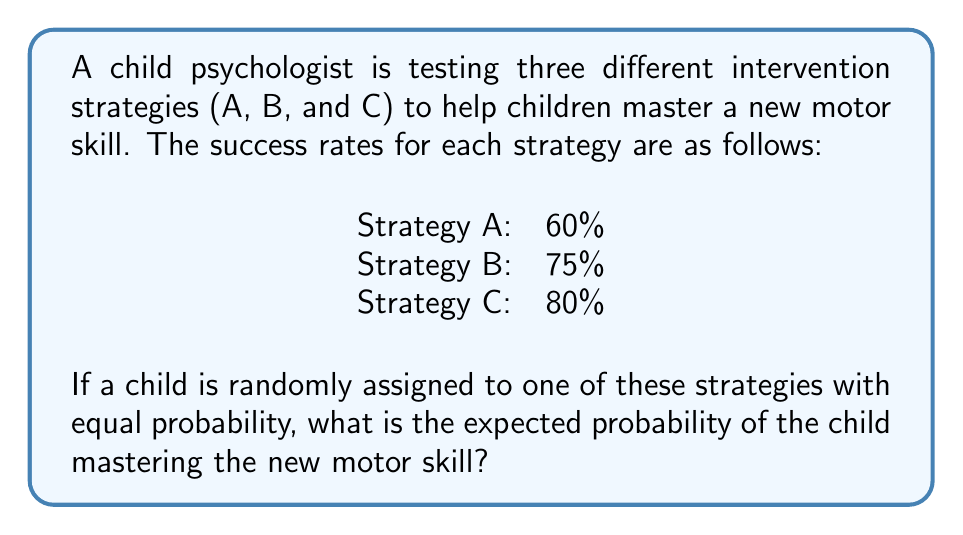Can you answer this question? Let's approach this step-by-step:

1) First, we need to understand what "expected probability" means in this context. It's the average probability of success considering all possible outcomes.

2) We can calculate this using the law of total probability. The formula is:

   $$P(\text{Success}) = \sum_{i=1}^{n} P(\text{Success}|\text{Strategy}_i) \cdot P(\text{Strategy}_i)$$

3) We know that each strategy has an equal probability of being chosen, so:

   $$P(\text{Strategy A}) = P(\text{Strategy B}) = P(\text{Strategy C}) = \frac{1}{3}$$

4) Now, let's plug in the values:

   $$P(\text{Success}) = 0.60 \cdot \frac{1}{3} + 0.75 \cdot \frac{1}{3} + 0.80 \cdot \frac{1}{3}$$

5) Simplify:

   $$P(\text{Success}) = \frac{0.60 + 0.75 + 0.80}{3} = \frac{2.15}{3}$$

6) Calculate the final result:

   $$P(\text{Success}) = 0.7166... \approx 0.72 \text{ or } 72\%$$

Therefore, the expected probability of a child mastering the new motor skill is approximately 72%.
Answer: 0.72 or 72% 